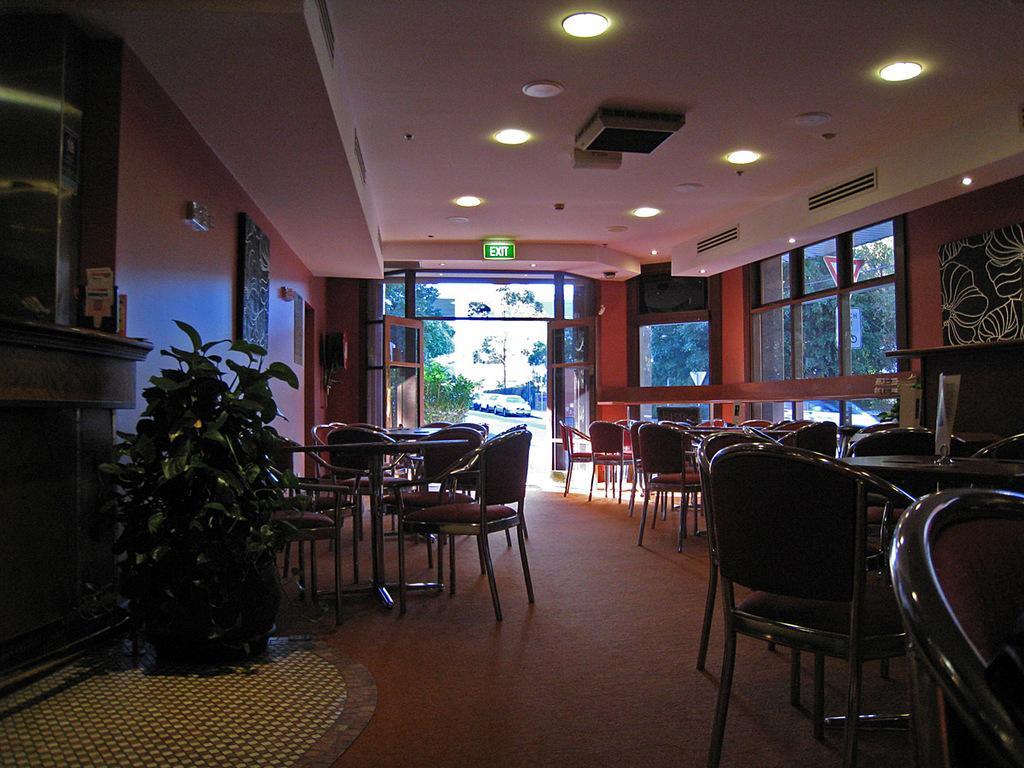How would you summarize this image in a sentence or two? In this image we can see some tables and the chairs which are placed on the floor. We can also see a plant in a pot, the sign boards, the air conditioners, boards on a wall, some objects on the table, a door and some ceiling lights to a roof. On the backside we can see some cars on the ground, a group of trees and the sky. 